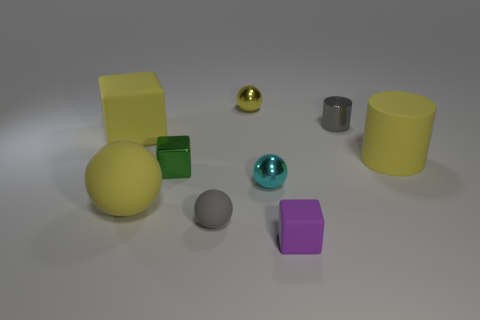Is the number of tiny cyan rubber cylinders greater than the number of small green blocks?
Make the answer very short. No. Do the yellow rubber cube and the matte cube in front of the large matte sphere have the same size?
Offer a terse response. No. The metal block that is in front of the small gray metallic cylinder is what color?
Give a very brief answer. Green. How many yellow things are either tiny metallic cylinders or large spheres?
Provide a succinct answer. 1. What color is the tiny rubber ball?
Offer a terse response. Gray. Are there any other things that are the same material as the cyan thing?
Offer a very short reply. Yes. Is the number of big matte objects that are on the right side of the green cube less than the number of rubber things behind the small cyan metallic ball?
Keep it short and to the point. Yes. There is a yellow thing that is both to the right of the green object and on the left side of the yellow cylinder; what is its shape?
Keep it short and to the point. Sphere. How many large yellow matte things have the same shape as the tiny gray shiny thing?
Offer a terse response. 1. What is the size of the green object that is made of the same material as the tiny yellow object?
Keep it short and to the point. Small. 